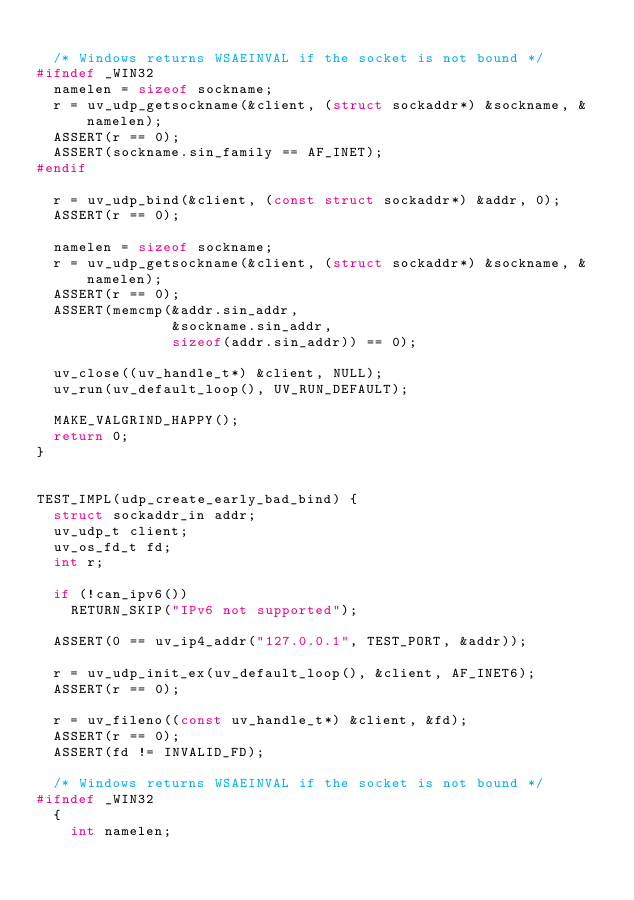Convert code to text. <code><loc_0><loc_0><loc_500><loc_500><_C_>
  /* Windows returns WSAEINVAL if the socket is not bound */
#ifndef _WIN32
  namelen = sizeof sockname;
  r = uv_udp_getsockname(&client, (struct sockaddr*) &sockname, &namelen);
  ASSERT(r == 0);
  ASSERT(sockname.sin_family == AF_INET);
#endif

  r = uv_udp_bind(&client, (const struct sockaddr*) &addr, 0);
  ASSERT(r == 0);

  namelen = sizeof sockname;
  r = uv_udp_getsockname(&client, (struct sockaddr*) &sockname, &namelen);
  ASSERT(r == 0);
  ASSERT(memcmp(&addr.sin_addr,
                &sockname.sin_addr,
                sizeof(addr.sin_addr)) == 0);

  uv_close((uv_handle_t*) &client, NULL);
  uv_run(uv_default_loop(), UV_RUN_DEFAULT);

  MAKE_VALGRIND_HAPPY();
  return 0;
}


TEST_IMPL(udp_create_early_bad_bind) {
  struct sockaddr_in addr;
  uv_udp_t client;
  uv_os_fd_t fd;
  int r;

  if (!can_ipv6())
    RETURN_SKIP("IPv6 not supported");

  ASSERT(0 == uv_ip4_addr("127.0.0.1", TEST_PORT, &addr));

  r = uv_udp_init_ex(uv_default_loop(), &client, AF_INET6);
  ASSERT(r == 0);

  r = uv_fileno((const uv_handle_t*) &client, &fd);
  ASSERT(r == 0);
  ASSERT(fd != INVALID_FD);

  /* Windows returns WSAEINVAL if the socket is not bound */
#ifndef _WIN32
  {
    int namelen;</code> 